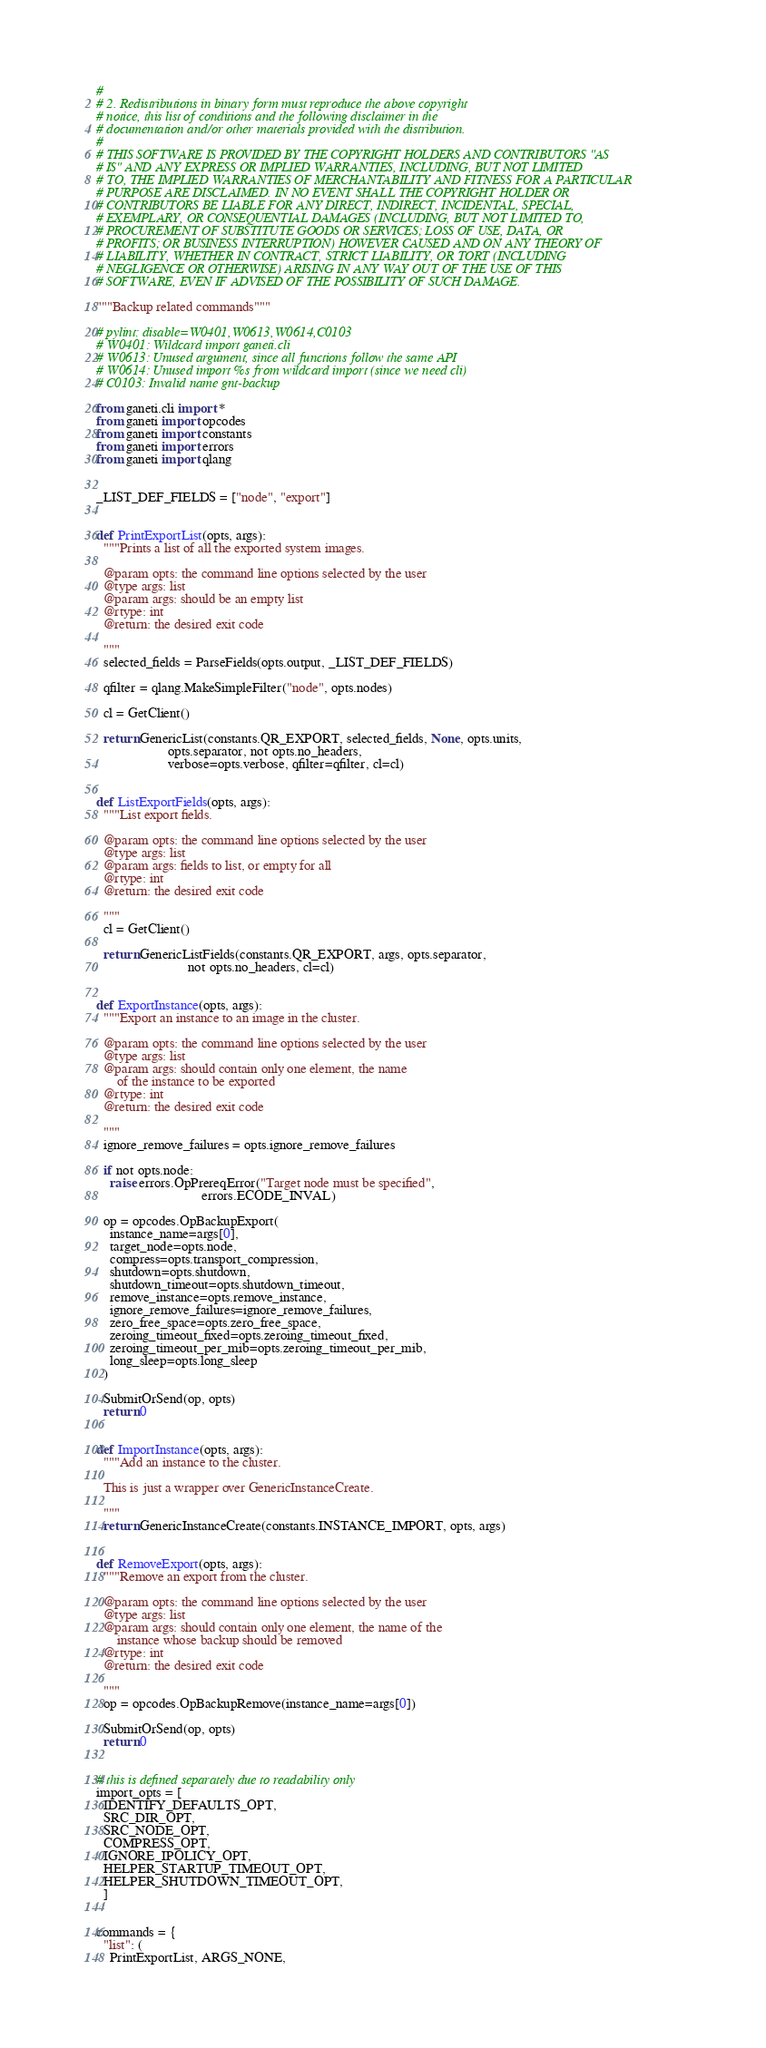Convert code to text. <code><loc_0><loc_0><loc_500><loc_500><_Python_>#
# 2. Redistributions in binary form must reproduce the above copyright
# notice, this list of conditions and the following disclaimer in the
# documentation and/or other materials provided with the distribution.
#
# THIS SOFTWARE IS PROVIDED BY THE COPYRIGHT HOLDERS AND CONTRIBUTORS "AS
# IS" AND ANY EXPRESS OR IMPLIED WARRANTIES, INCLUDING, BUT NOT LIMITED
# TO, THE IMPLIED WARRANTIES OF MERCHANTABILITY AND FITNESS FOR A PARTICULAR
# PURPOSE ARE DISCLAIMED. IN NO EVENT SHALL THE COPYRIGHT HOLDER OR
# CONTRIBUTORS BE LIABLE FOR ANY DIRECT, INDIRECT, INCIDENTAL, SPECIAL,
# EXEMPLARY, OR CONSEQUENTIAL DAMAGES (INCLUDING, BUT NOT LIMITED TO,
# PROCUREMENT OF SUBSTITUTE GOODS OR SERVICES; LOSS OF USE, DATA, OR
# PROFITS; OR BUSINESS INTERRUPTION) HOWEVER CAUSED AND ON ANY THEORY OF
# LIABILITY, WHETHER IN CONTRACT, STRICT LIABILITY, OR TORT (INCLUDING
# NEGLIGENCE OR OTHERWISE) ARISING IN ANY WAY OUT OF THE USE OF THIS
# SOFTWARE, EVEN IF ADVISED OF THE POSSIBILITY OF SUCH DAMAGE.

"""Backup related commands"""

# pylint: disable=W0401,W0613,W0614,C0103
# W0401: Wildcard import ganeti.cli
# W0613: Unused argument, since all functions follow the same API
# W0614: Unused import %s from wildcard import (since we need cli)
# C0103: Invalid name gnt-backup

from ganeti.cli import *
from ganeti import opcodes
from ganeti import constants
from ganeti import errors
from ganeti import qlang


_LIST_DEF_FIELDS = ["node", "export"]


def PrintExportList(opts, args):
  """Prints a list of all the exported system images.

  @param opts: the command line options selected by the user
  @type args: list
  @param args: should be an empty list
  @rtype: int
  @return: the desired exit code

  """
  selected_fields = ParseFields(opts.output, _LIST_DEF_FIELDS)

  qfilter = qlang.MakeSimpleFilter("node", opts.nodes)

  cl = GetClient()

  return GenericList(constants.QR_EXPORT, selected_fields, None, opts.units,
                     opts.separator, not opts.no_headers,
                     verbose=opts.verbose, qfilter=qfilter, cl=cl)


def ListExportFields(opts, args):
  """List export fields.

  @param opts: the command line options selected by the user
  @type args: list
  @param args: fields to list, or empty for all
  @rtype: int
  @return: the desired exit code

  """
  cl = GetClient()

  return GenericListFields(constants.QR_EXPORT, args, opts.separator,
                           not opts.no_headers, cl=cl)


def ExportInstance(opts, args):
  """Export an instance to an image in the cluster.

  @param opts: the command line options selected by the user
  @type args: list
  @param args: should contain only one element, the name
      of the instance to be exported
  @rtype: int
  @return: the desired exit code

  """
  ignore_remove_failures = opts.ignore_remove_failures

  if not opts.node:
    raise errors.OpPrereqError("Target node must be specified",
                               errors.ECODE_INVAL)

  op = opcodes.OpBackupExport(
    instance_name=args[0],
    target_node=opts.node,
    compress=opts.transport_compression,
    shutdown=opts.shutdown,
    shutdown_timeout=opts.shutdown_timeout,
    remove_instance=opts.remove_instance,
    ignore_remove_failures=ignore_remove_failures,
    zero_free_space=opts.zero_free_space,
    zeroing_timeout_fixed=opts.zeroing_timeout_fixed,
    zeroing_timeout_per_mib=opts.zeroing_timeout_per_mib,
    long_sleep=opts.long_sleep
  )

  SubmitOrSend(op, opts)
  return 0


def ImportInstance(opts, args):
  """Add an instance to the cluster.

  This is just a wrapper over GenericInstanceCreate.

  """
  return GenericInstanceCreate(constants.INSTANCE_IMPORT, opts, args)


def RemoveExport(opts, args):
  """Remove an export from the cluster.

  @param opts: the command line options selected by the user
  @type args: list
  @param args: should contain only one element, the name of the
      instance whose backup should be removed
  @rtype: int
  @return: the desired exit code

  """
  op = opcodes.OpBackupRemove(instance_name=args[0])

  SubmitOrSend(op, opts)
  return 0


# this is defined separately due to readability only
import_opts = [
  IDENTIFY_DEFAULTS_OPT,
  SRC_DIR_OPT,
  SRC_NODE_OPT,
  COMPRESS_OPT,
  IGNORE_IPOLICY_OPT,
  HELPER_STARTUP_TIMEOUT_OPT,
  HELPER_SHUTDOWN_TIMEOUT_OPT,
  ]


commands = {
  "list": (
    PrintExportList, ARGS_NONE,</code> 